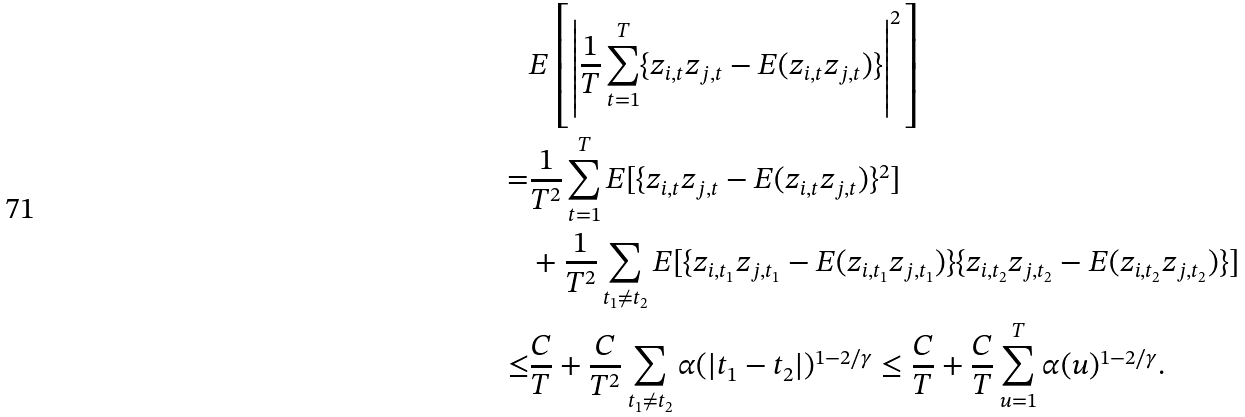<formula> <loc_0><loc_0><loc_500><loc_500>& E \left [ \left | \frac { 1 } { T } \sum _ { t = 1 } ^ { T } \{ z _ { i , t } z _ { j , t } - E ( z _ { i , t } z _ { j , t } ) \} \right | ^ { 2 } \right ] \\ = & \frac { 1 } { T ^ { 2 } } \sum _ { t = 1 } ^ { T } E [ \{ z _ { i , t } z _ { j , t } - E ( z _ { i , t } z _ { j , t } ) \} ^ { 2 } ] \\ & + \frac { 1 } { T ^ { 2 } } \sum _ { t _ { 1 } \neq t _ { 2 } } E [ \{ z _ { i , t _ { 1 } } z _ { j , t _ { 1 } } - E ( z _ { i , t _ { 1 } } z _ { j , t _ { 1 } } ) \} \{ z _ { i , t _ { 2 } } z _ { j , t _ { 2 } } - E ( z _ { i , t _ { 2 } } z _ { j , t _ { 2 } } ) \} ] \\ \leq & \frac { C } { T } + \frac { C } { T ^ { 2 } } \sum _ { t _ { 1 } \neq t _ { 2 } } \alpha ( | t _ { 1 } - t _ { 2 } | ) ^ { 1 - 2 / \gamma } \leq \frac { C } { T } + \frac { C } { T } \sum _ { u = 1 } ^ { T } \alpha ( u ) ^ { 1 - 2 / \gamma } .</formula> 